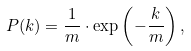<formula> <loc_0><loc_0><loc_500><loc_500>P ( k ) = \frac { 1 } { m } \cdot \exp \left ( - \frac { k } { m } \right ) ,</formula> 